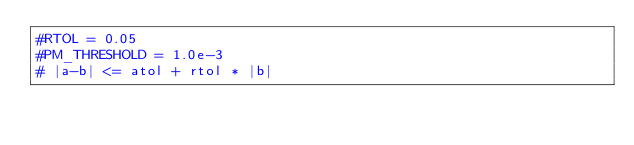<code> <loc_0><loc_0><loc_500><loc_500><_Python_>#RTOL = 0.05
#PM_THRESHOLD = 1.0e-3
# |a-b| <= atol + rtol * |b|
</code> 